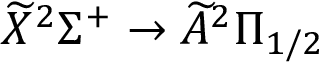Convert formula to latex. <formula><loc_0><loc_0><loc_500><loc_500>\widetilde { X } ^ { 2 } \Sigma ^ { + } \rightarrow \widetilde { A } ^ { 2 } \Pi _ { 1 / 2 }</formula> 